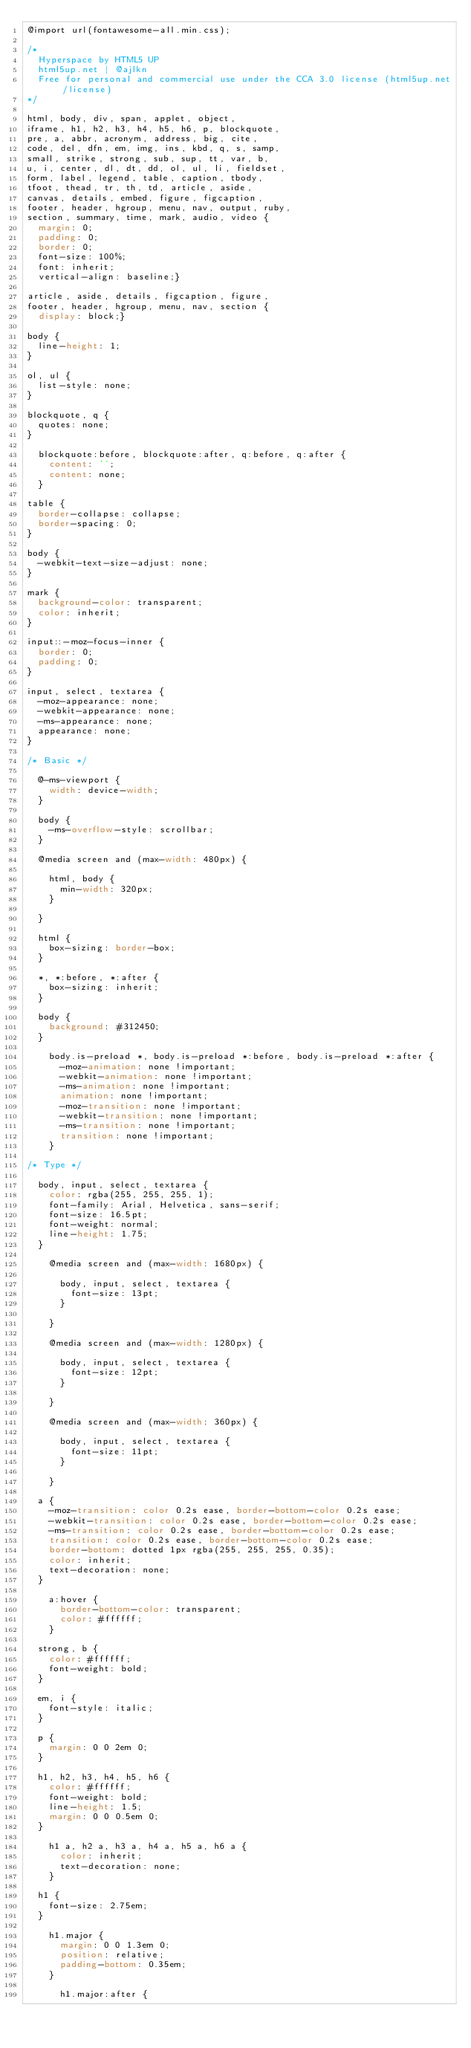Convert code to text. <code><loc_0><loc_0><loc_500><loc_500><_CSS_>@import url(fontawesome-all.min.css);

/*
	Hyperspace by HTML5 UP
	html5up.net | @ajlkn
	Free for personal and commercial use under the CCA 3.0 license (html5up.net/license)
*/

html, body, div, span, applet, object,
iframe, h1, h2, h3, h4, h5, h6, p, blockquote,
pre, a, abbr, acronym, address, big, cite,
code, del, dfn, em, img, ins, kbd, q, s, samp,
small, strike, strong, sub, sup, tt, var, b,
u, i, center, dl, dt, dd, ol, ul, li, fieldset,
form, label, legend, table, caption, tbody,
tfoot, thead, tr, th, td, article, aside,
canvas, details, embed, figure, figcaption,
footer, header, hgroup, menu, nav, output, ruby,
section, summary, time, mark, audio, video {
	margin: 0;
	padding: 0;
	border: 0;
	font-size: 100%;
	font: inherit;
	vertical-align: baseline;}

article, aside, details, figcaption, figure,
footer, header, hgroup, menu, nav, section {
	display: block;}

body {
	line-height: 1;
}

ol, ul {
	list-style: none;
}

blockquote, q {
	quotes: none;
}

	blockquote:before, blockquote:after, q:before, q:after {
		content: '';
		content: none;
	}

table {
	border-collapse: collapse;
	border-spacing: 0;
}

body {
	-webkit-text-size-adjust: none;
}

mark {
	background-color: transparent;
	color: inherit;
}

input::-moz-focus-inner {
	border: 0;
	padding: 0;
}

input, select, textarea {
	-moz-appearance: none;
	-webkit-appearance: none;
	-ms-appearance: none;
	appearance: none;
}

/* Basic */

	@-ms-viewport {
		width: device-width;
	}

	body {
		-ms-overflow-style: scrollbar;
	}

	@media screen and (max-width: 480px) {

		html, body {
			min-width: 320px;
		}

	}

	html {
		box-sizing: border-box;
	}

	*, *:before, *:after {
		box-sizing: inherit;
	}

	body {
		background: #312450;
	}

		body.is-preload *, body.is-preload *:before, body.is-preload *:after {
			-moz-animation: none !important;
			-webkit-animation: none !important;
			-ms-animation: none !important;
			animation: none !important;
			-moz-transition: none !important;
			-webkit-transition: none !important;
			-ms-transition: none !important;
			transition: none !important;
		}

/* Type */

	body, input, select, textarea {
		color: rgba(255, 255, 255, 1);
		font-family: Arial, Helvetica, sans-serif;
		font-size: 16.5pt;
		font-weight: normal;
		line-height: 1.75;
	}

		@media screen and (max-width: 1680px) {

			body, input, select, textarea {
				font-size: 13pt;
			}

		}

		@media screen and (max-width: 1280px) {

			body, input, select, textarea {
				font-size: 12pt;
			}

		}

		@media screen and (max-width: 360px) {

			body, input, select, textarea {
				font-size: 11pt;
			}

		}

	a {
		-moz-transition: color 0.2s ease, border-bottom-color 0.2s ease;
		-webkit-transition: color 0.2s ease, border-bottom-color 0.2s ease;
		-ms-transition: color 0.2s ease, border-bottom-color 0.2s ease;
		transition: color 0.2s ease, border-bottom-color 0.2s ease;
		border-bottom: dotted 1px rgba(255, 255, 255, 0.35);
		color: inherit;
		text-decoration: none;
	}

		a:hover {
			border-bottom-color: transparent;
			color: #ffffff;
		}

	strong, b {
		color: #ffffff;
		font-weight: bold;
	}

	em, i {
		font-style: italic;
	}

	p {
		margin: 0 0 2em 0;
	}

	h1, h2, h3, h4, h5, h6 {
		color: #ffffff;
		font-weight: bold;
		line-height: 1.5;
		margin: 0 0 0.5em 0;
	}

		h1 a, h2 a, h3 a, h4 a, h5 a, h6 a {
			color: inherit;
			text-decoration: none;
		}

	h1 {
		font-size: 2.75em;
	}

		h1.major {
			margin: 0 0 1.3em 0;
			position: relative;
			padding-bottom: 0.35em;
		}

			h1.major:after {</code> 